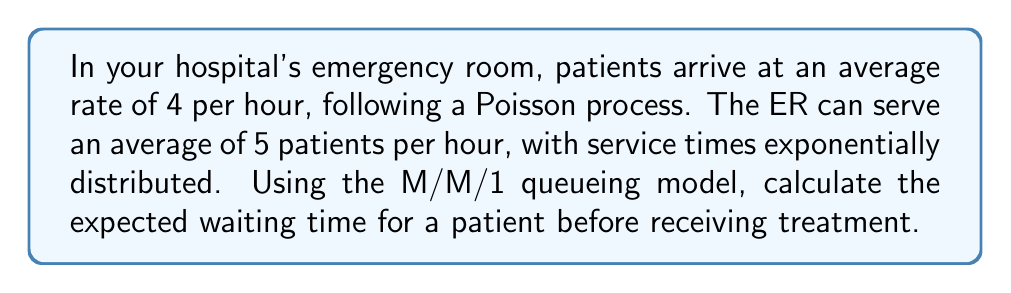Can you solve this math problem? To solve this problem, we'll use the M/M/1 queueing model:

1. Identify the parameters:
   $\lambda$ = arrival rate = 4 patients/hour
   $\mu$ = service rate = 5 patients/hour

2. Calculate the utilization factor $\rho$:
   $\rho = \frac{\lambda}{\mu} = \frac{4}{5} = 0.8$

3. Calculate the expected number of patients in the system $L$:
   $L = \frac{\rho}{1-\rho} = \frac{0.8}{1-0.8} = 4$ patients

4. Calculate the expected time in the system $W$ using Little's Law:
   $W = \frac{L}{\lambda} = \frac{4}{4} = 1$ hour

5. Calculate the expected service time $\frac{1}{\mu}$:
   $\frac{1}{\mu} = \frac{1}{5} = 0.2$ hours

6. Calculate the expected waiting time $W_q$:
   $W_q = W - \frac{1}{\mu} = 1 - 0.2 = 0.8$ hours

Convert the result to minutes:
$0.8 \text{ hours} \times 60 \text{ minutes/hour} = 48 \text{ minutes}$
Answer: 48 minutes 